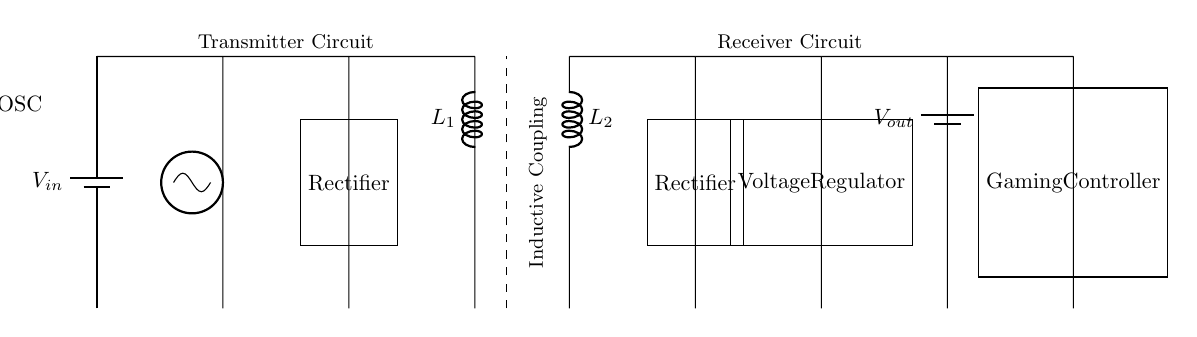What is the function of the battery labeled Vout? The battery labeled Vout serves as the power source for the gaming controller, providing the necessary voltage for its operation after the signal has been rectified and regulated.
Answer: Power source for gaming controller What are the two inductors present in the circuit? The two inductors in the circuit are labeled L1 and L2, representing the primary and secondary coils used for inductive coupling in the wireless charging system.
Answer: L1 and L2 How many rectifiers are there in the circuit? There are two rectifiers in the circuit, one for the transmitter circuit (after the oscillator) and one for the receiver circuit (after the secondary coil).
Answer: Two What type of coupling is used in this charging circuit? The circuit uses inductive coupling, which allows the transfer of energy from the primary coil to the secondary coil without direct electrical connections.
Answer: Inductive coupling Which component regulates the output voltage to the gaming controller? The voltage regulator component is responsible for ensuring that the output voltage supplied to the gaming controller is stable and within the required range.
Answer: Voltage regulator What is the role of the oscillator in this circuit? The oscillator generates an alternating current signal, which is necessary for creating a magnetic field in the primary coil that drives the inductive coupling.
Answer: Generate AC signal 